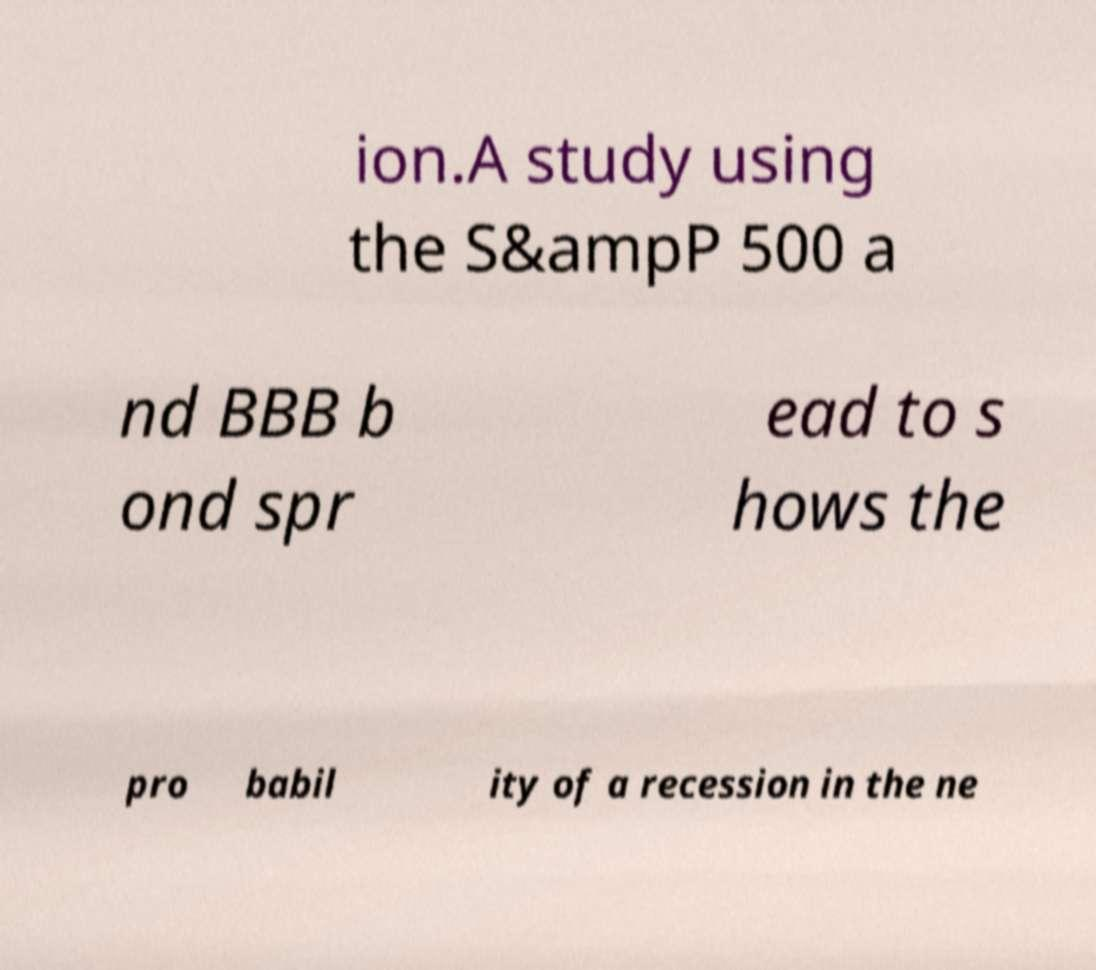Please identify and transcribe the text found in this image. ion.A study using the S&ampP 500 a nd BBB b ond spr ead to s hows the pro babil ity of a recession in the ne 